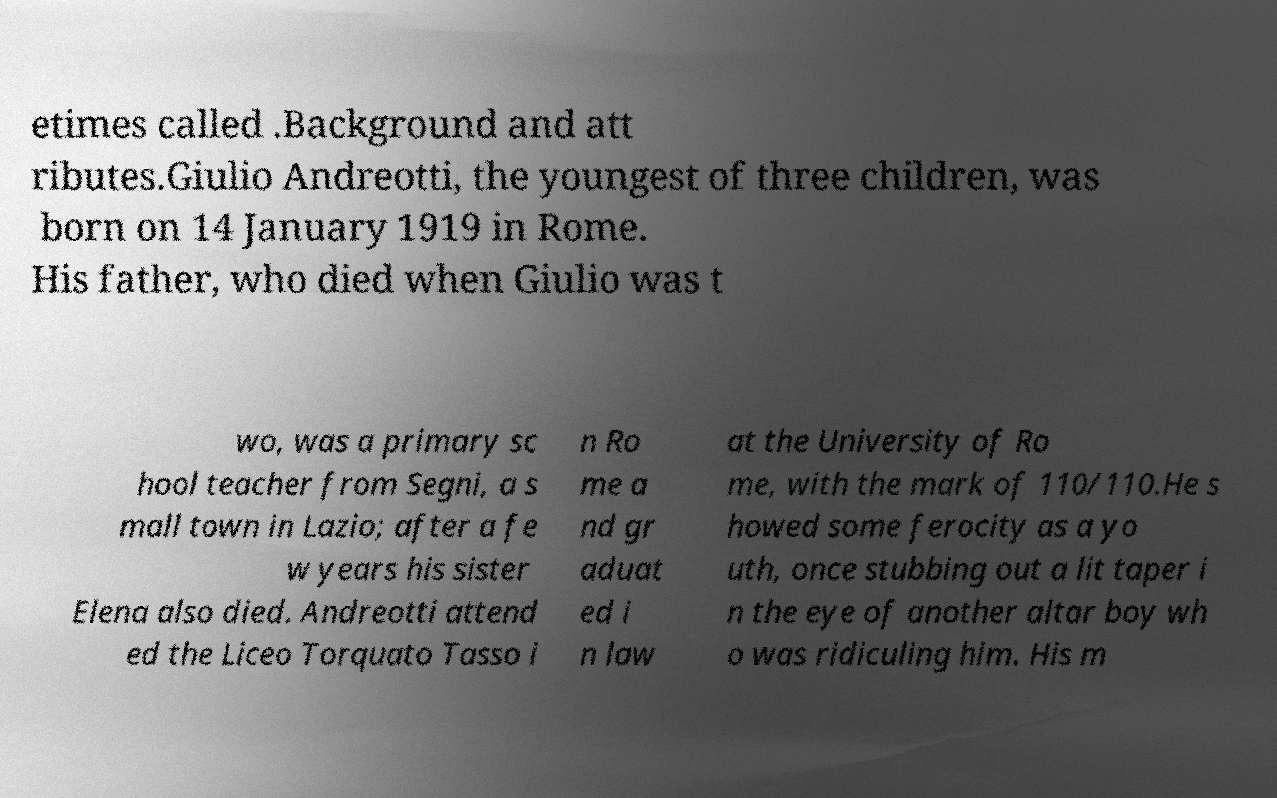There's text embedded in this image that I need extracted. Can you transcribe it verbatim? etimes called .Background and att ributes.Giulio Andreotti, the youngest of three children, was born on 14 January 1919 in Rome. His father, who died when Giulio was t wo, was a primary sc hool teacher from Segni, a s mall town in Lazio; after a fe w years his sister Elena also died. Andreotti attend ed the Liceo Torquato Tasso i n Ro me a nd gr aduat ed i n law at the University of Ro me, with the mark of 110/110.He s howed some ferocity as a yo uth, once stubbing out a lit taper i n the eye of another altar boy wh o was ridiculing him. His m 